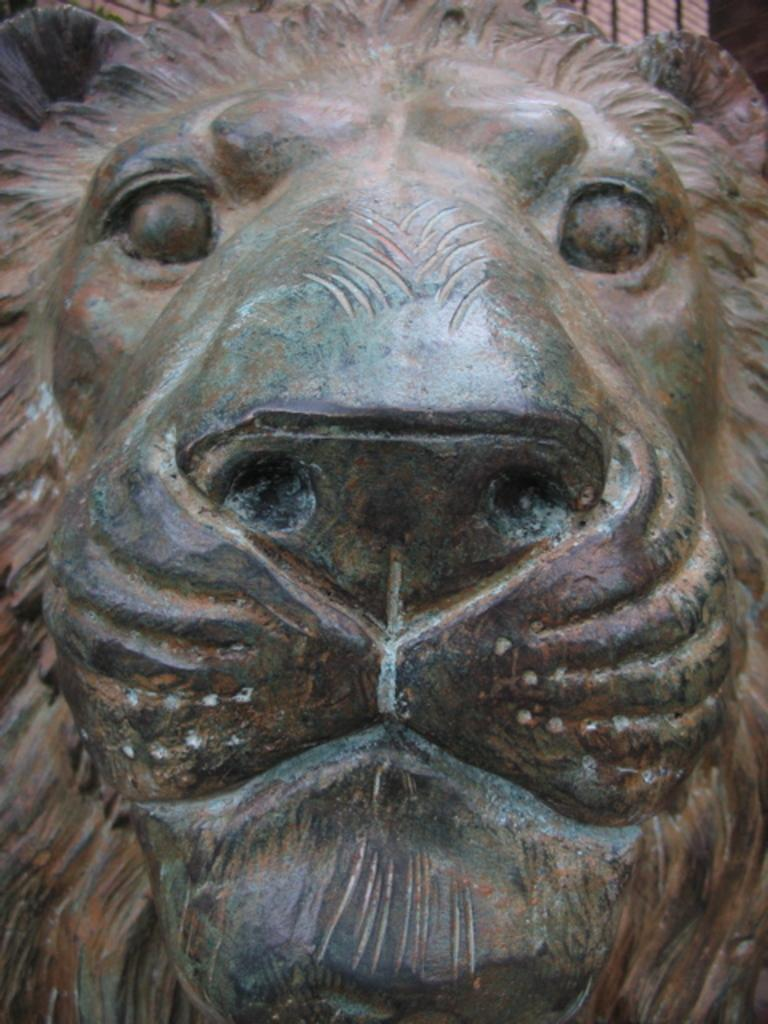What is the main subject of the image? There is a statue in the image. Can you describe the statue in more detail? The statue is of a lion. What invention is being demonstrated by the sheep in the image? There are no sheep present in the image, and therefore no invention can be demonstrated by them. 